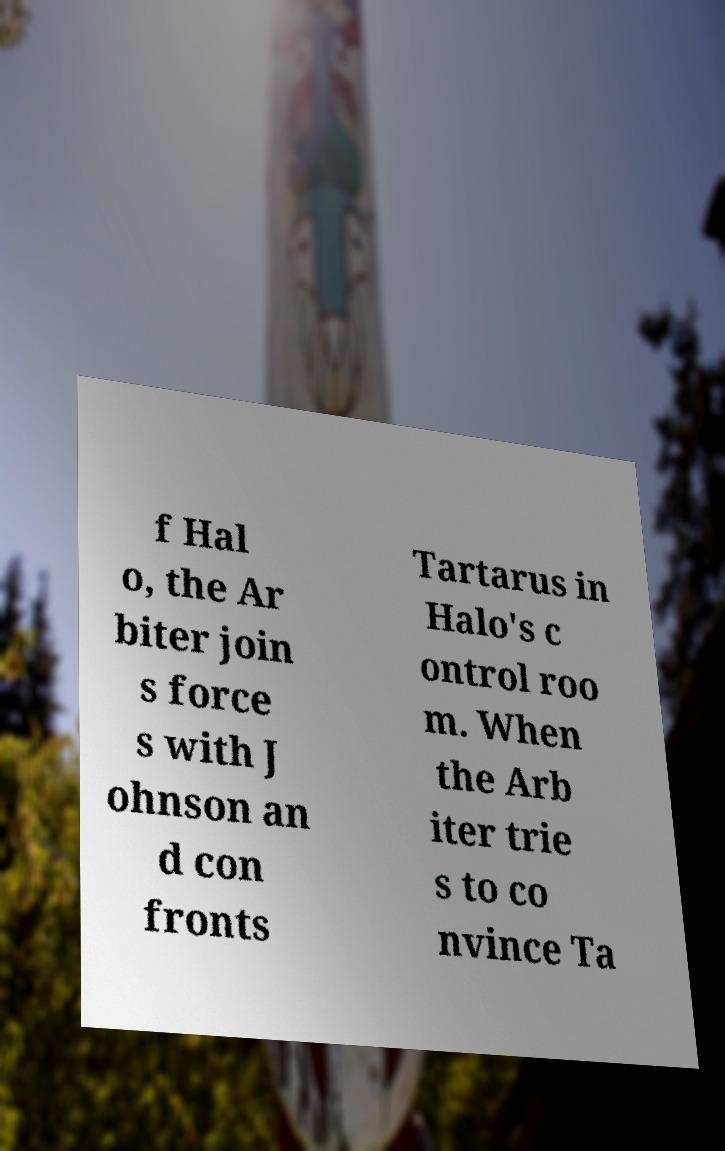I need the written content from this picture converted into text. Can you do that? f Hal o, the Ar biter join s force s with J ohnson an d con fronts Tartarus in Halo's c ontrol roo m. When the Arb iter trie s to co nvince Ta 